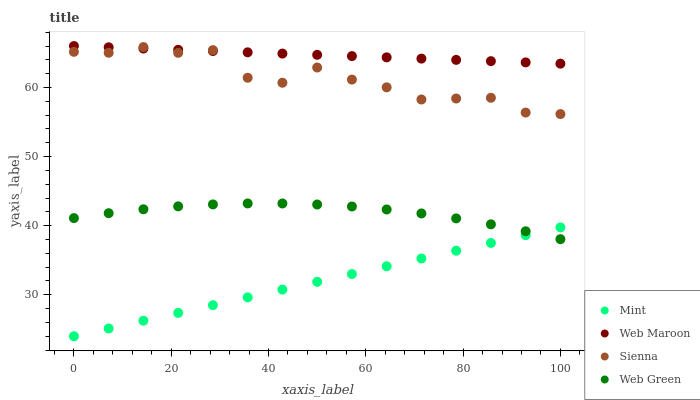Does Mint have the minimum area under the curve?
Answer yes or no. Yes. Does Web Maroon have the maximum area under the curve?
Answer yes or no. Yes. Does Web Maroon have the minimum area under the curve?
Answer yes or no. No. Does Mint have the maximum area under the curve?
Answer yes or no. No. Is Mint the smoothest?
Answer yes or no. Yes. Is Sienna the roughest?
Answer yes or no. Yes. Is Web Maroon the smoothest?
Answer yes or no. No. Is Web Maroon the roughest?
Answer yes or no. No. Does Mint have the lowest value?
Answer yes or no. Yes. Does Web Maroon have the lowest value?
Answer yes or no. No. Does Web Maroon have the highest value?
Answer yes or no. Yes. Does Mint have the highest value?
Answer yes or no. No. Is Mint less than Web Maroon?
Answer yes or no. Yes. Is Sienna greater than Mint?
Answer yes or no. Yes. Does Web Maroon intersect Sienna?
Answer yes or no. Yes. Is Web Maroon less than Sienna?
Answer yes or no. No. Is Web Maroon greater than Sienna?
Answer yes or no. No. Does Mint intersect Web Maroon?
Answer yes or no. No. 